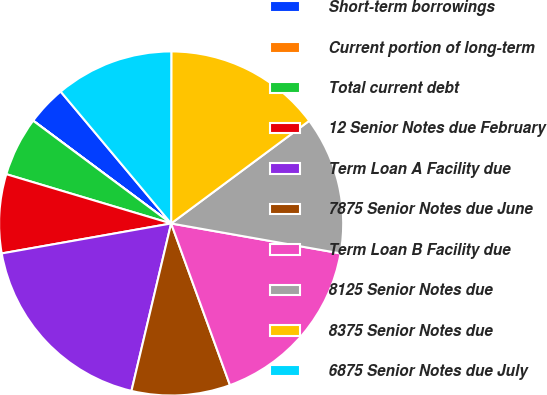Convert chart. <chart><loc_0><loc_0><loc_500><loc_500><pie_chart><fcel>Short-term borrowings<fcel>Current portion of long-term<fcel>Total current debt<fcel>12 Senior Notes due February<fcel>Term Loan A Facility due<fcel>7875 Senior Notes due June<fcel>Term Loan B Facility due<fcel>8125 Senior Notes due<fcel>8375 Senior Notes due<fcel>6875 Senior Notes due July<nl><fcel>3.71%<fcel>0.01%<fcel>5.56%<fcel>7.41%<fcel>18.51%<fcel>9.26%<fcel>16.66%<fcel>12.96%<fcel>14.81%<fcel>11.11%<nl></chart> 